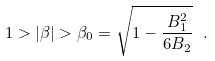Convert formula to latex. <formula><loc_0><loc_0><loc_500><loc_500>1 > | \beta | > \beta _ { 0 } = \sqrt { 1 - \frac { B _ { 1 } ^ { 2 } } { 6 B _ { 2 } } } \ .</formula> 